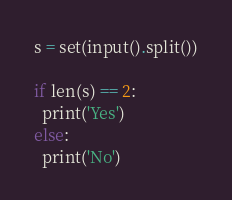<code> <loc_0><loc_0><loc_500><loc_500><_Python_>s = set(input().split())
 
if len(s) == 2:
  print('Yes')
else:
  print('No')</code> 